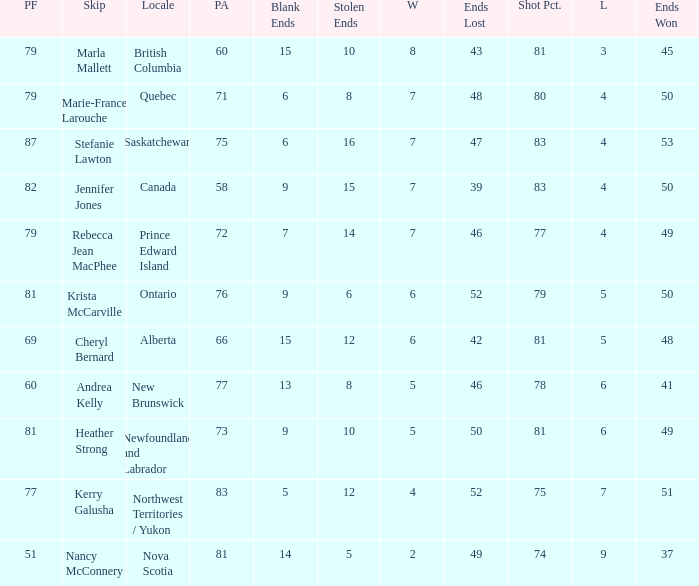What is the total of blank ends at Prince Edward Island? 7.0. 